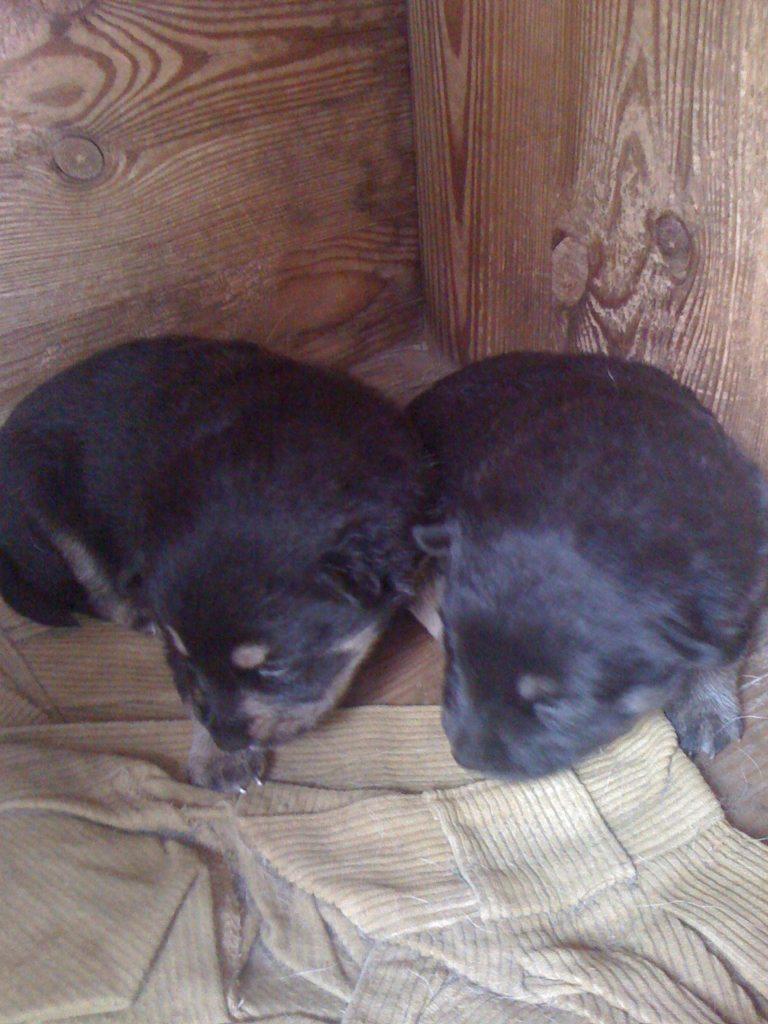Describe this image in one or two sentences. In this picture we can see two animals and a cloth on the wooden surface. In the background we can see the walls. 